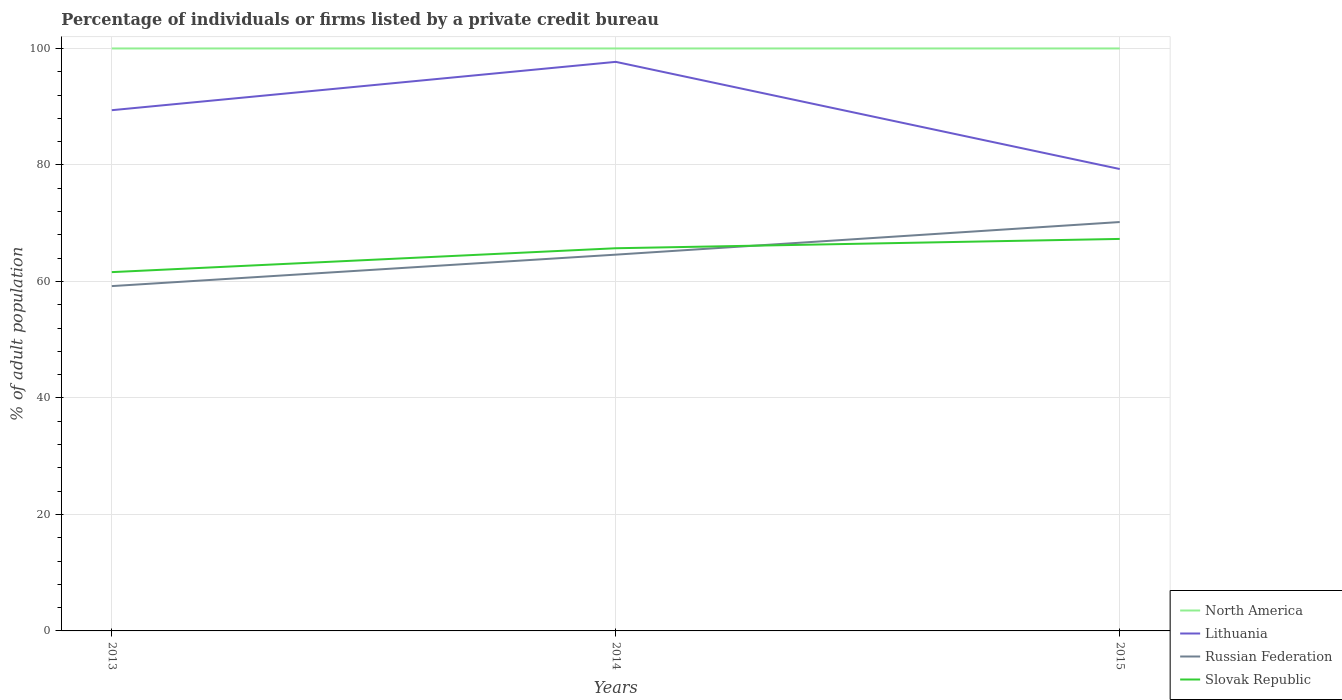Is the number of lines equal to the number of legend labels?
Make the answer very short. Yes. Across all years, what is the maximum percentage of population listed by a private credit bureau in Russian Federation?
Provide a succinct answer. 59.2. What is the total percentage of population listed by a private credit bureau in Slovak Republic in the graph?
Provide a short and direct response. -4.1. What is the difference between the highest and the second highest percentage of population listed by a private credit bureau in Russian Federation?
Give a very brief answer. 11. What is the difference between the highest and the lowest percentage of population listed by a private credit bureau in Slovak Republic?
Your answer should be very brief. 2. How many lines are there?
Make the answer very short. 4. What is the difference between two consecutive major ticks on the Y-axis?
Give a very brief answer. 20. Does the graph contain any zero values?
Provide a succinct answer. No. Does the graph contain grids?
Your response must be concise. Yes. How many legend labels are there?
Provide a short and direct response. 4. How are the legend labels stacked?
Make the answer very short. Vertical. What is the title of the graph?
Offer a very short reply. Percentage of individuals or firms listed by a private credit bureau. What is the label or title of the Y-axis?
Provide a short and direct response. % of adult population. What is the % of adult population in North America in 2013?
Ensure brevity in your answer.  100. What is the % of adult population of Lithuania in 2013?
Give a very brief answer. 89.4. What is the % of adult population of Russian Federation in 2013?
Ensure brevity in your answer.  59.2. What is the % of adult population in Slovak Republic in 2013?
Offer a terse response. 61.6. What is the % of adult population in Lithuania in 2014?
Make the answer very short. 97.7. What is the % of adult population of Russian Federation in 2014?
Your answer should be very brief. 64.6. What is the % of adult population in Slovak Republic in 2014?
Provide a short and direct response. 65.7. What is the % of adult population in Lithuania in 2015?
Provide a short and direct response. 79.3. What is the % of adult population of Russian Federation in 2015?
Ensure brevity in your answer.  70.2. What is the % of adult population of Slovak Republic in 2015?
Offer a very short reply. 67.3. Across all years, what is the maximum % of adult population in Lithuania?
Provide a succinct answer. 97.7. Across all years, what is the maximum % of adult population of Russian Federation?
Ensure brevity in your answer.  70.2. Across all years, what is the maximum % of adult population in Slovak Republic?
Offer a very short reply. 67.3. Across all years, what is the minimum % of adult population of North America?
Your answer should be compact. 100. Across all years, what is the minimum % of adult population of Lithuania?
Provide a short and direct response. 79.3. Across all years, what is the minimum % of adult population in Russian Federation?
Your answer should be very brief. 59.2. Across all years, what is the minimum % of adult population of Slovak Republic?
Make the answer very short. 61.6. What is the total % of adult population of North America in the graph?
Make the answer very short. 300. What is the total % of adult population in Lithuania in the graph?
Ensure brevity in your answer.  266.4. What is the total % of adult population in Russian Federation in the graph?
Your answer should be very brief. 194. What is the total % of adult population of Slovak Republic in the graph?
Make the answer very short. 194.6. What is the difference between the % of adult population in Lithuania in 2013 and that in 2015?
Keep it short and to the point. 10.1. What is the difference between the % of adult population of North America in 2014 and that in 2015?
Give a very brief answer. 0. What is the difference between the % of adult population of Russian Federation in 2014 and that in 2015?
Keep it short and to the point. -5.6. What is the difference between the % of adult population in North America in 2013 and the % of adult population in Lithuania in 2014?
Your answer should be compact. 2.3. What is the difference between the % of adult population of North America in 2013 and the % of adult population of Russian Federation in 2014?
Make the answer very short. 35.4. What is the difference between the % of adult population in North America in 2013 and the % of adult population in Slovak Republic in 2014?
Your response must be concise. 34.3. What is the difference between the % of adult population in Lithuania in 2013 and the % of adult population in Russian Federation in 2014?
Make the answer very short. 24.8. What is the difference between the % of adult population in Lithuania in 2013 and the % of adult population in Slovak Republic in 2014?
Give a very brief answer. 23.7. What is the difference between the % of adult population of Russian Federation in 2013 and the % of adult population of Slovak Republic in 2014?
Keep it short and to the point. -6.5. What is the difference between the % of adult population in North America in 2013 and the % of adult population in Lithuania in 2015?
Offer a terse response. 20.7. What is the difference between the % of adult population of North America in 2013 and the % of adult population of Russian Federation in 2015?
Provide a short and direct response. 29.8. What is the difference between the % of adult population in North America in 2013 and the % of adult population in Slovak Republic in 2015?
Make the answer very short. 32.7. What is the difference between the % of adult population in Lithuania in 2013 and the % of adult population in Russian Federation in 2015?
Your answer should be very brief. 19.2. What is the difference between the % of adult population in Lithuania in 2013 and the % of adult population in Slovak Republic in 2015?
Provide a succinct answer. 22.1. What is the difference between the % of adult population of North America in 2014 and the % of adult population of Lithuania in 2015?
Give a very brief answer. 20.7. What is the difference between the % of adult population of North America in 2014 and the % of adult population of Russian Federation in 2015?
Keep it short and to the point. 29.8. What is the difference between the % of adult population of North America in 2014 and the % of adult population of Slovak Republic in 2015?
Your answer should be very brief. 32.7. What is the difference between the % of adult population of Lithuania in 2014 and the % of adult population of Russian Federation in 2015?
Give a very brief answer. 27.5. What is the difference between the % of adult population of Lithuania in 2014 and the % of adult population of Slovak Republic in 2015?
Keep it short and to the point. 30.4. What is the difference between the % of adult population in Russian Federation in 2014 and the % of adult population in Slovak Republic in 2015?
Your answer should be compact. -2.7. What is the average % of adult population in North America per year?
Your answer should be very brief. 100. What is the average % of adult population of Lithuania per year?
Provide a short and direct response. 88.8. What is the average % of adult population of Russian Federation per year?
Offer a terse response. 64.67. What is the average % of adult population of Slovak Republic per year?
Provide a short and direct response. 64.87. In the year 2013, what is the difference between the % of adult population in North America and % of adult population in Russian Federation?
Offer a terse response. 40.8. In the year 2013, what is the difference between the % of adult population in North America and % of adult population in Slovak Republic?
Offer a very short reply. 38.4. In the year 2013, what is the difference between the % of adult population in Lithuania and % of adult population in Russian Federation?
Ensure brevity in your answer.  30.2. In the year 2013, what is the difference between the % of adult population in Lithuania and % of adult population in Slovak Republic?
Keep it short and to the point. 27.8. In the year 2014, what is the difference between the % of adult population of North America and % of adult population of Lithuania?
Your answer should be compact. 2.3. In the year 2014, what is the difference between the % of adult population of North America and % of adult population of Russian Federation?
Provide a short and direct response. 35.4. In the year 2014, what is the difference between the % of adult population of North America and % of adult population of Slovak Republic?
Offer a very short reply. 34.3. In the year 2014, what is the difference between the % of adult population of Lithuania and % of adult population of Russian Federation?
Your answer should be very brief. 33.1. In the year 2014, what is the difference between the % of adult population of Lithuania and % of adult population of Slovak Republic?
Keep it short and to the point. 32. In the year 2014, what is the difference between the % of adult population in Russian Federation and % of adult population in Slovak Republic?
Provide a succinct answer. -1.1. In the year 2015, what is the difference between the % of adult population in North America and % of adult population in Lithuania?
Your response must be concise. 20.7. In the year 2015, what is the difference between the % of adult population of North America and % of adult population of Russian Federation?
Ensure brevity in your answer.  29.8. In the year 2015, what is the difference between the % of adult population of North America and % of adult population of Slovak Republic?
Your answer should be compact. 32.7. In the year 2015, what is the difference between the % of adult population in Lithuania and % of adult population in Russian Federation?
Keep it short and to the point. 9.1. In the year 2015, what is the difference between the % of adult population in Lithuania and % of adult population in Slovak Republic?
Make the answer very short. 12. What is the ratio of the % of adult population of North America in 2013 to that in 2014?
Provide a succinct answer. 1. What is the ratio of the % of adult population of Lithuania in 2013 to that in 2014?
Provide a succinct answer. 0.92. What is the ratio of the % of adult population in Russian Federation in 2013 to that in 2014?
Your answer should be very brief. 0.92. What is the ratio of the % of adult population in Slovak Republic in 2013 to that in 2014?
Provide a succinct answer. 0.94. What is the ratio of the % of adult population in Lithuania in 2013 to that in 2015?
Keep it short and to the point. 1.13. What is the ratio of the % of adult population of Russian Federation in 2013 to that in 2015?
Your answer should be very brief. 0.84. What is the ratio of the % of adult population in Slovak Republic in 2013 to that in 2015?
Provide a short and direct response. 0.92. What is the ratio of the % of adult population in Lithuania in 2014 to that in 2015?
Offer a very short reply. 1.23. What is the ratio of the % of adult population of Russian Federation in 2014 to that in 2015?
Your response must be concise. 0.92. What is the ratio of the % of adult population in Slovak Republic in 2014 to that in 2015?
Offer a very short reply. 0.98. What is the difference between the highest and the second highest % of adult population in North America?
Your response must be concise. 0. What is the difference between the highest and the second highest % of adult population in Lithuania?
Make the answer very short. 8.3. What is the difference between the highest and the second highest % of adult population of Slovak Republic?
Ensure brevity in your answer.  1.6. What is the difference between the highest and the lowest % of adult population of Lithuania?
Your answer should be very brief. 18.4. What is the difference between the highest and the lowest % of adult population of Russian Federation?
Your answer should be very brief. 11. 